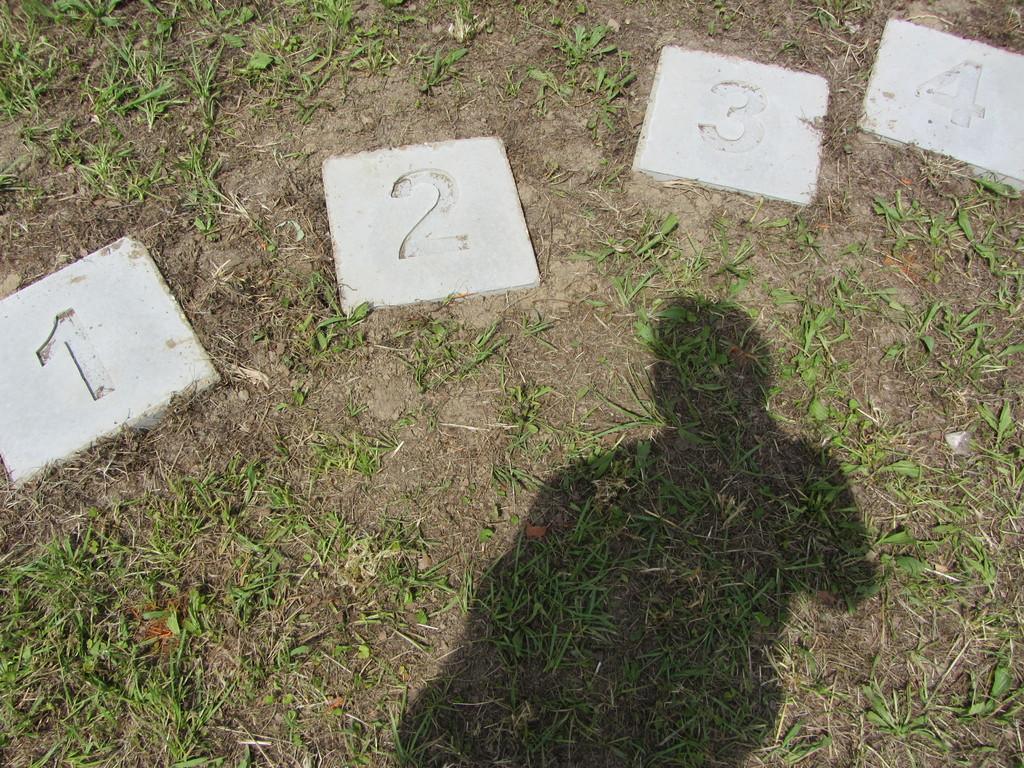Please provide a concise description of this image. In this image we can see shadow of a person. we can see grass at the bottom of the image. There are tiles with numerical number printed on it. 